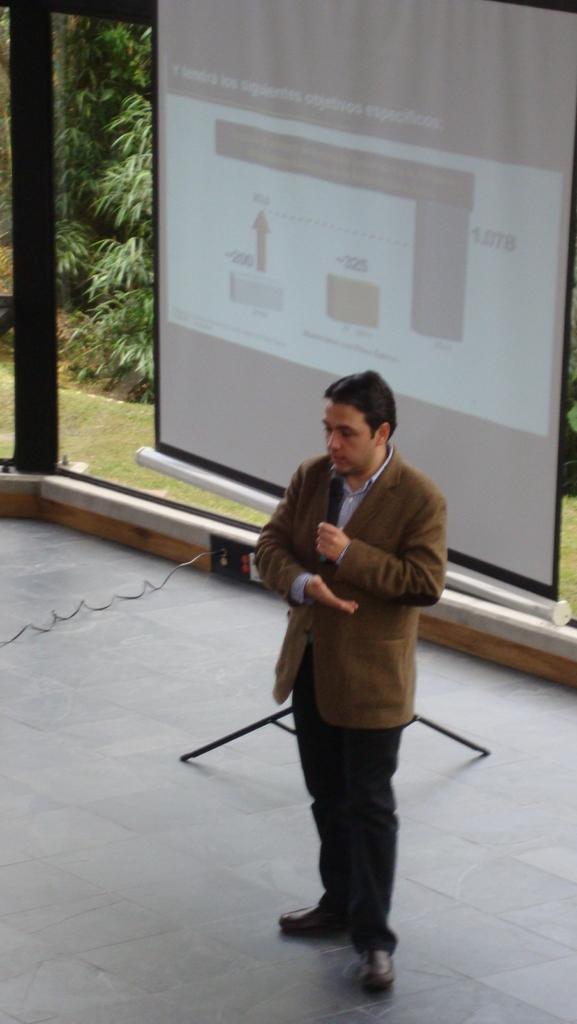How would you summarize this image in a sentence or two? A man is standing on the floor and holding a mic in his hand. In the background there is a stand and cable on the floor and there is a screen and glass doors. Through the glass doors we can see trees and grass on the ground. 